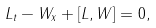Convert formula to latex. <formula><loc_0><loc_0><loc_500><loc_500>L _ { t } - W _ { x } + \left [ L , W \right ] = 0 ,</formula> 